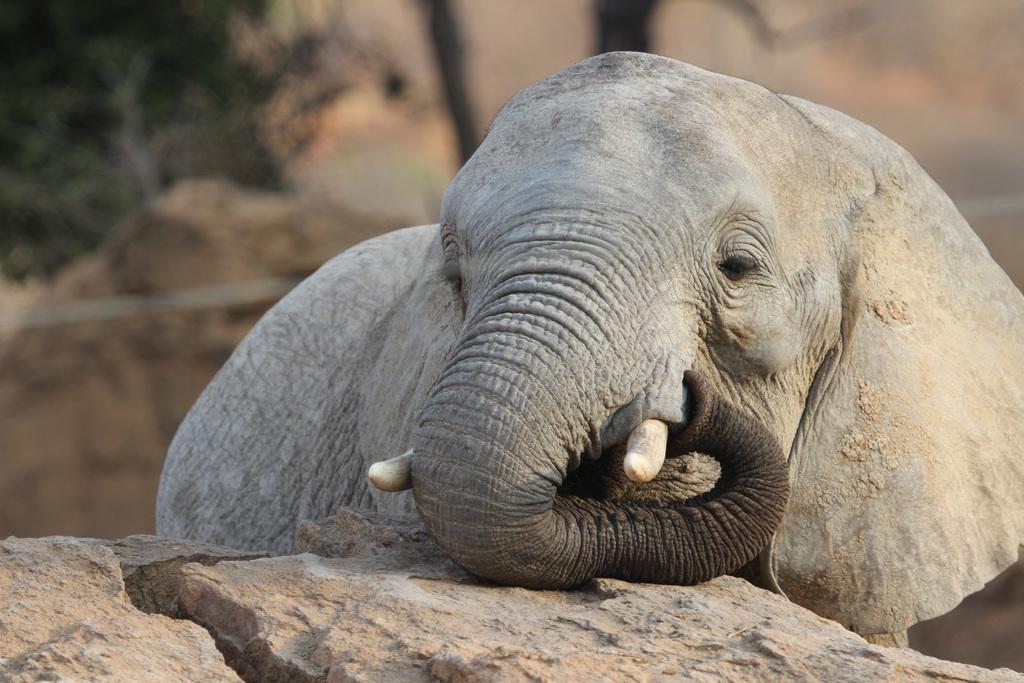Can you describe this image briefly? In this image on the ground there is an elephant. The background is blurred. 